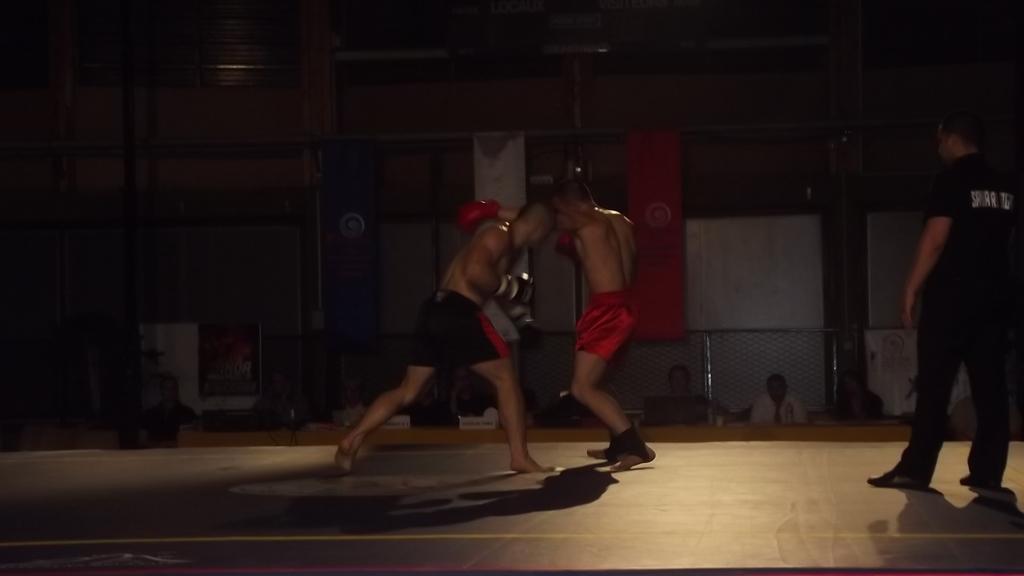In one or two sentences, can you explain what this image depicts? In this image I can see 2 people wrestling. A person is standing on the right, wearing a black dress. Other people are sitting at the back and there are 2 flags hanging. 